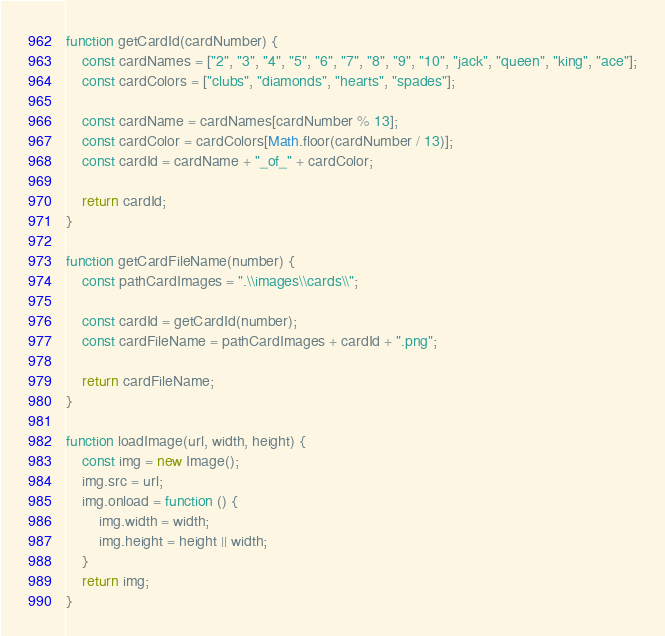<code> <loc_0><loc_0><loc_500><loc_500><_JavaScript_>function getCardId(cardNumber) {
    const cardNames = ["2", "3", "4", "5", "6", "7", "8", "9", "10", "jack", "queen", "king", "ace"];
    const cardColors = ["clubs", "diamonds", "hearts", "spades"];

    const cardName = cardNames[cardNumber % 13];
    const cardColor = cardColors[Math.floor(cardNumber / 13)];
    const cardId = cardName + "_of_" + cardColor;

    return cardId;
}

function getCardFileName(number) {
    const pathCardImages = ".\\images\\cards\\";

    const cardId = getCardId(number);
    const cardFileName = pathCardImages + cardId + ".png";

    return cardFileName;
}

function loadImage(url, width, height) {
    const img = new Image();
    img.src = url;
    img.onload = function () {
        img.width = width;
        img.height = height || width;
    }
    return img;
}
</code> 